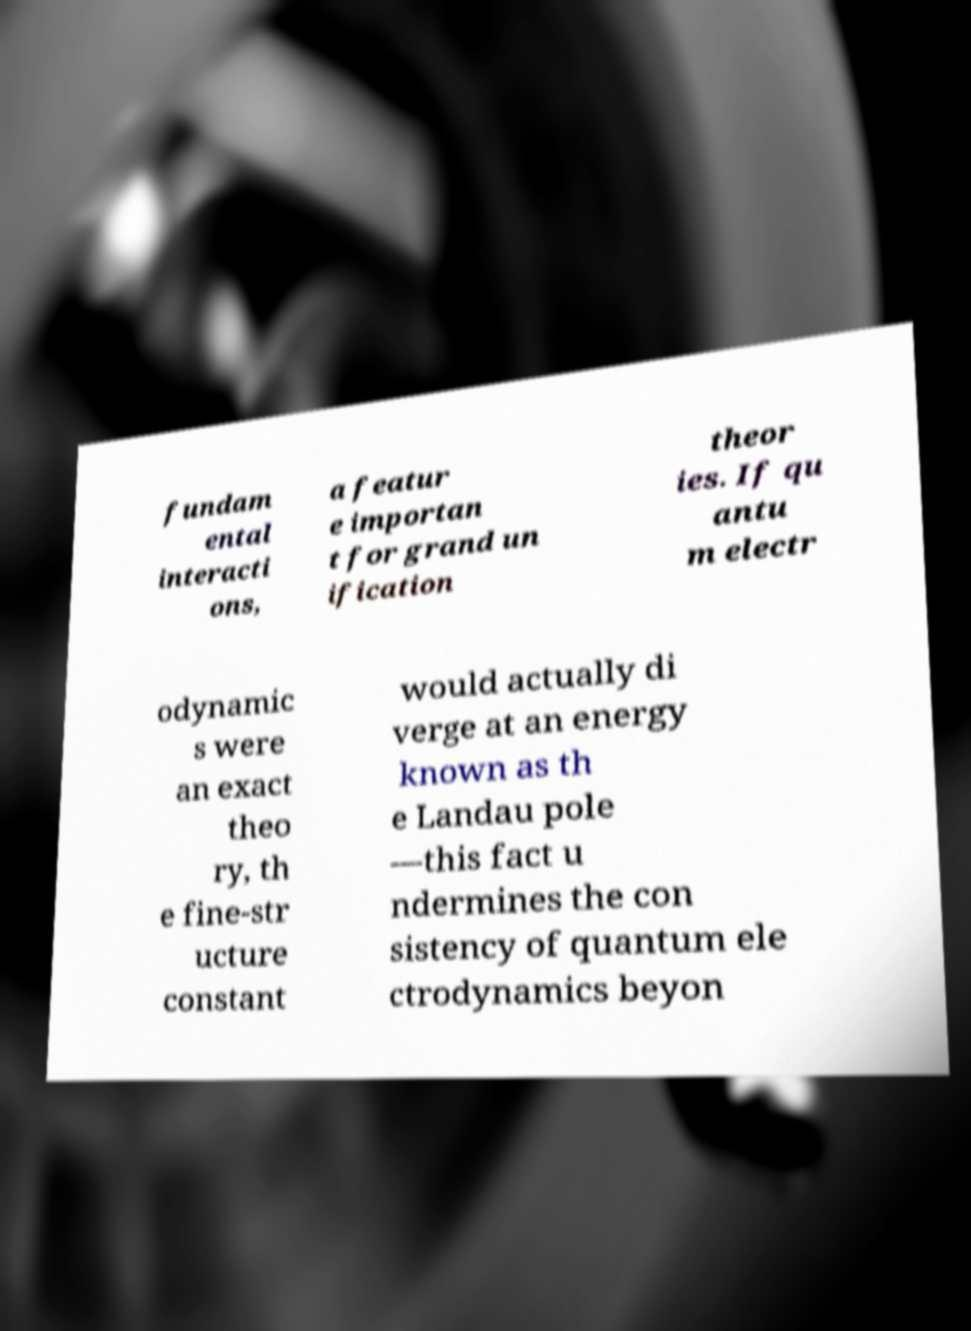Could you extract and type out the text from this image? fundam ental interacti ons, a featur e importan t for grand un ification theor ies. If qu antu m electr odynamic s were an exact theo ry, th e fine-str ucture constant would actually di verge at an energy known as th e Landau pole —this fact u ndermines the con sistency of quantum ele ctrodynamics beyon 